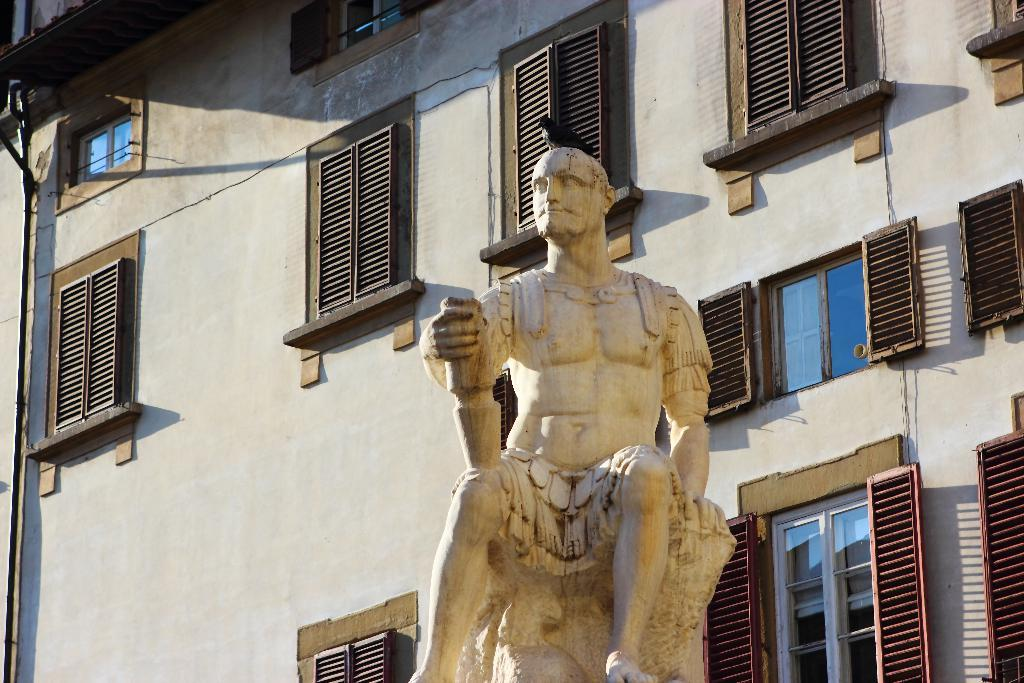What is the main subject of the image? There is a statue of a person sitting in the image. What can be seen behind the statue? There is a building with windows behind the statue. Are there any other living creatures in the image besides the statue? Yes, there is a bird on the statue. Reasoning: Let's think step by identifying the main subject of the image, which is the statue of a person sitting. Then, we describe the background by mentioning the building with windows. Finally, we acknowledge the presence of another living creature, the bird, which is on the statue. Absurd Question/Answer: What type of lettuce is growing on the farm in the image? There is no farm or lettuce present in the image; it features a statue of a person sitting with a bird on it and a building with windows in the background. What type of crime is being committed in the image? There is no crime being committed in the image; it features a statue of a person sitting with a bird on it and a building with windows in the background. 